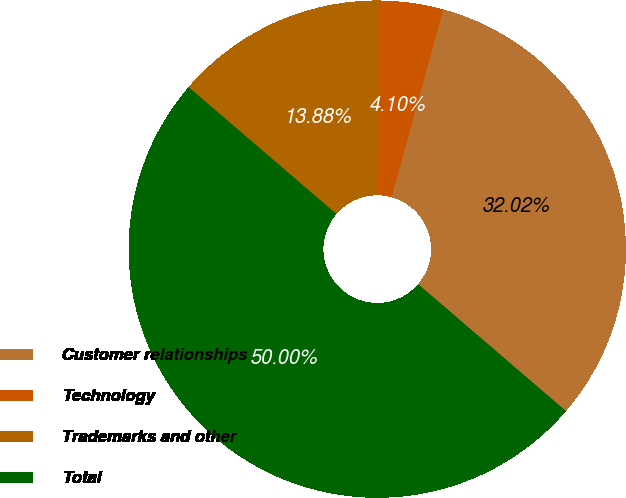Convert chart. <chart><loc_0><loc_0><loc_500><loc_500><pie_chart><fcel>Customer relationships<fcel>Technology<fcel>Trademarks and other<fcel>Total<nl><fcel>32.02%<fcel>4.1%<fcel>13.88%<fcel>50.0%<nl></chart> 